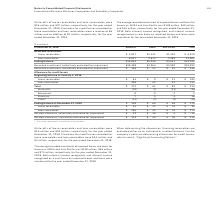According to International Business Machines's financial document, How much was the write-offs of lease and loan receivables for December 2018? Write-offs of lease receivables and loan receivables were $15 million and $20 million, respectively, for the year ended December 31, 2018.. The document states: "Write-offs of lease receivables and loan receivables were $15 million and $20 million, respectively, for the year ended December 31, 2018. Provisions ..." Also, What is the average recorded investment of impaired leases and loans for Americas, EMEA and Asia Pacific for December 2018? The average recorded investment of impaired leases and loans for Americas, EMEA and Asia Pacific was $138 million, $55 million and $73 million, respectively, for the year ended December 31, 2018.. The document states: "The average recorded investment of impaired leases and loans for Americas, EMEA and Asia Pacific was $138 million, $55 million and $73 million, respec..." Also, How much credit losses were recorded for lease and loan receivables for December 2018? Provisions for credit losses recorded for lease receivables and loan receivables were $14 million and $2 million, respectively, for the year ended December 31, 2018.. The document states: "espectively, for the year ended December 31, 2018. Provisions for credit losses recorded for lease receivables and loan receivables were $14 million a..." Also, can you calculate: What is the average Recorded investment of Loan receivables for Americas and EMEA for December 2018? To answer this question, I need to perform calculations using the financial data. The calculation is: (6,817+3,675) / 2, which equals 5246 (in millions). This is based on the information: "Loan receivables 6,817 3,675 2,489 12,981 Loan receivables 6,817 3,675 2,489 12,981..." The key data points involved are: 3,675, 6,817. Also, can you calculate: What is the average Allowance for credit losses of Lease receivables at the beginning of January 2018? Based on the calculation: 103 / 3, the result is 34.33 (in millions). This is based on the information: "Lease receivables $ 63 $ 9 $ 31 $ 103 Lease receivables $ 63 $ 9 $ 31 $ 103..." The key data points involved are: 103. Also, can you calculate: What is the average Recorded investment of Lease receivables for Americas and EMEA for December 2018? To answer this question, I need to perform calculations using the financial data. The calculation is: (3,827+1,341) / 2, which equals 2584 (in millions). This is based on the information: "Lease receivables $ 3,827 $1,341 $1,152 $ 6,320 Lease receivables $ 3,827 $1,341 $1,152 $ 6,320..." The key data points involved are: 1,341, 3,827. 